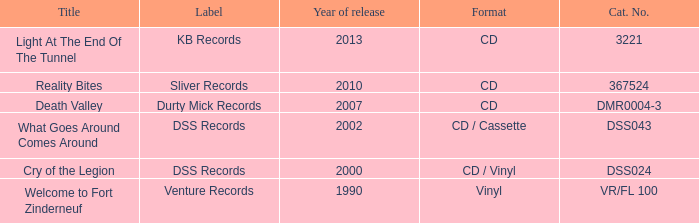What is the latest year of the album with the release title death valley? 2007.0. 